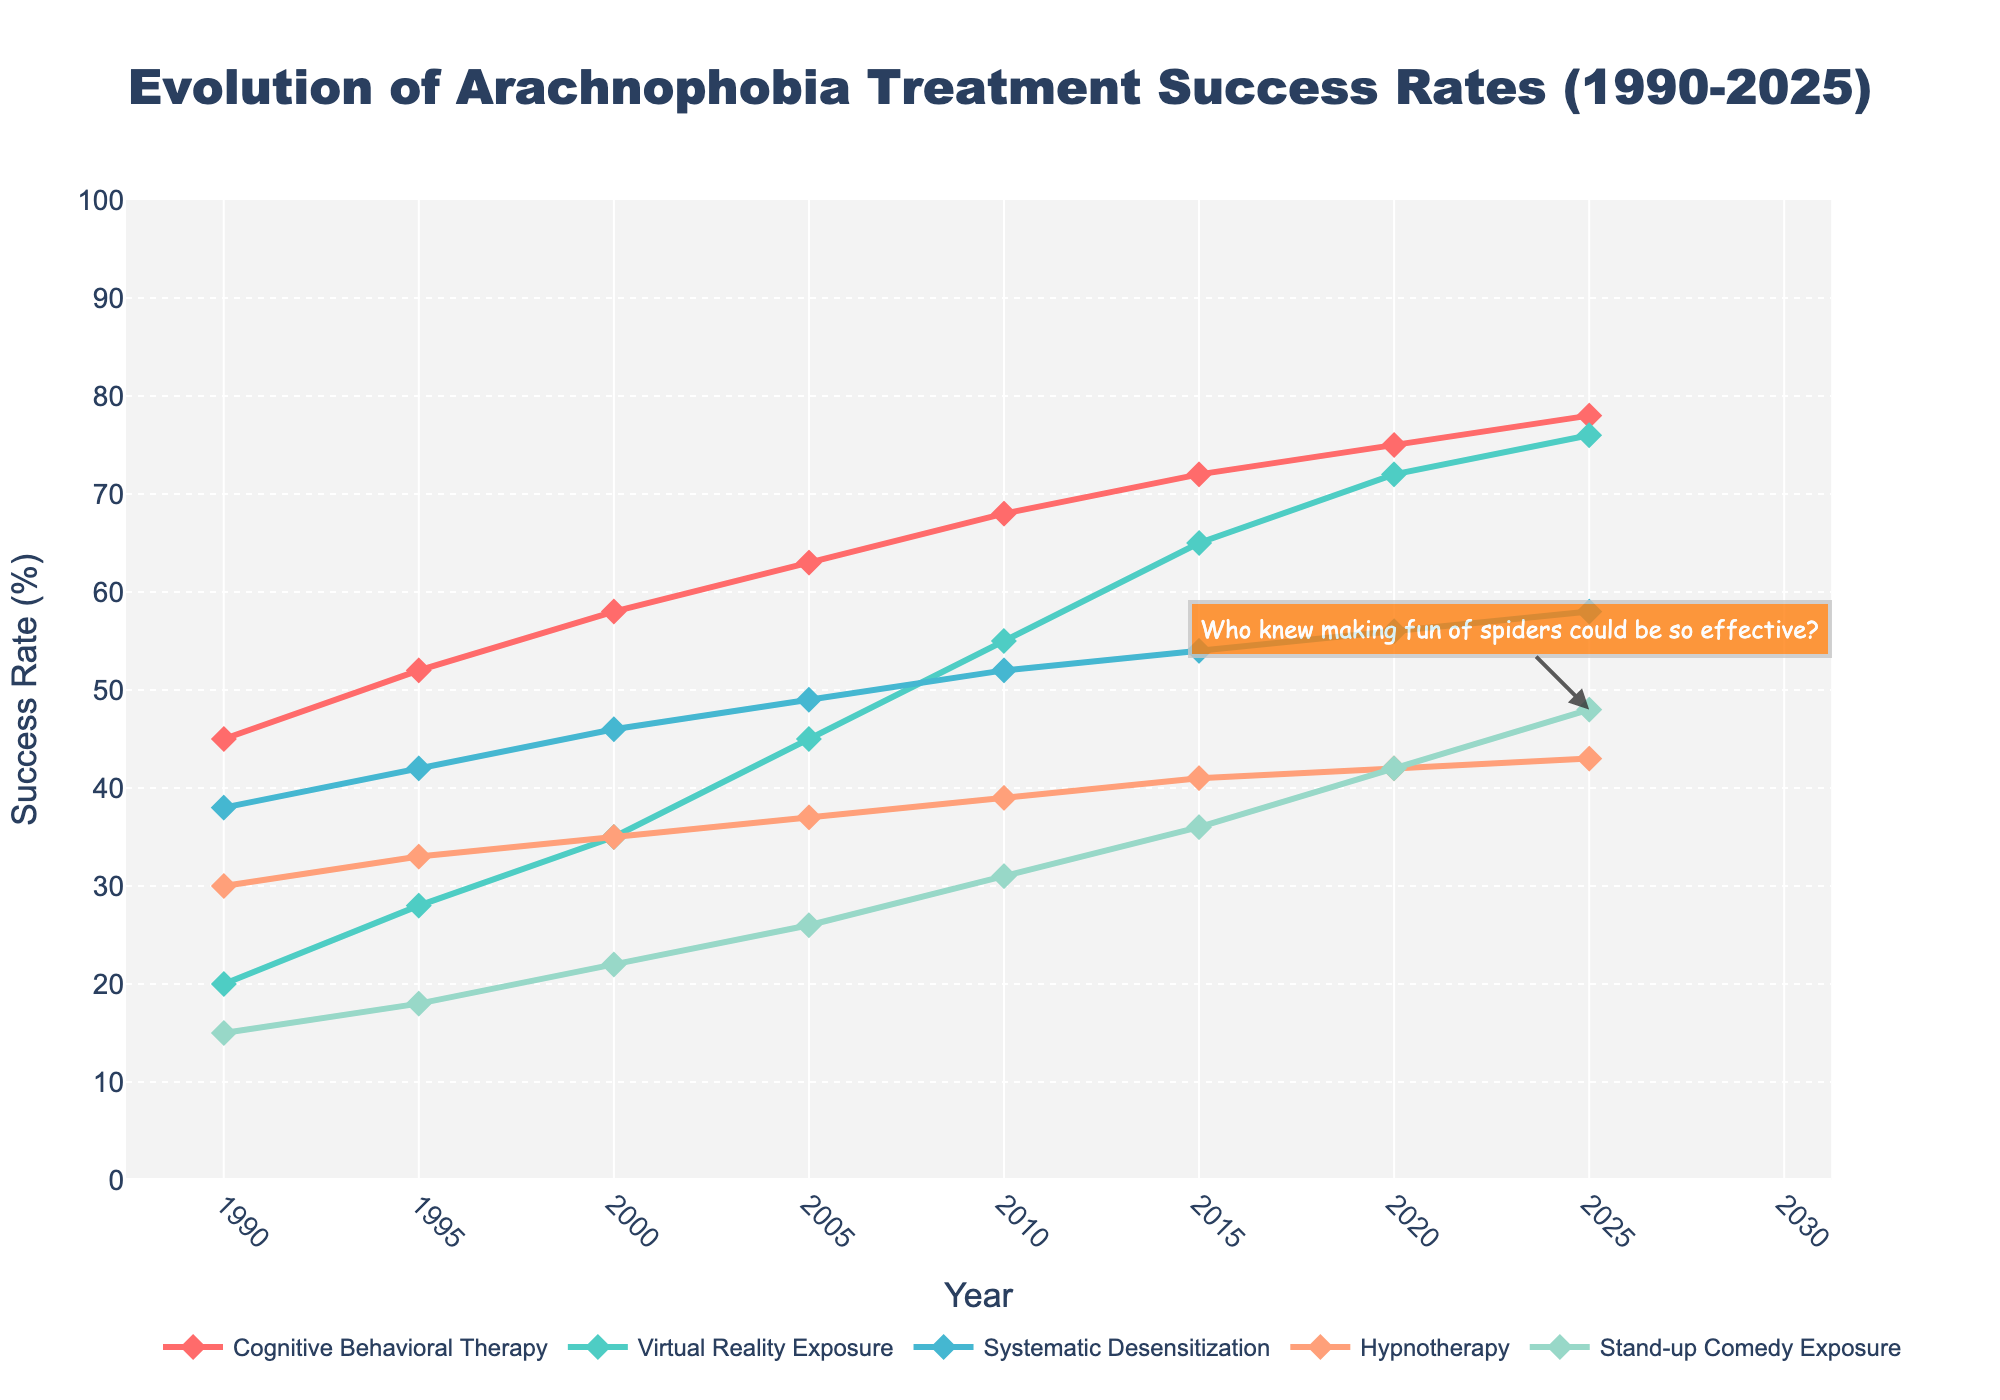What is the success rate of Cognitive Behavioral Therapy (CBT) in 2005? Look for the data point corresponding to Cognitive Behavioral Therapy in the year 2005 on the chart and read the value.
Answer: 63% Which therapy had the lowest success rate in 1995? Compare the success rates of all therapies in the year 1995 and identify the smallest value.
Answer: Stand-up Comedy Exposure How much did the success rate of Virtual Reality Exposure (VRE) increase from 2000 to 2020? Subtract the success rate of Virtual Reality Exposure in 2000 (35) from its rate in 2020 (72).
Answer: 37% In which year did Stand-up Comedy Exposure first surpass a 30% success rate? Identify the year when Stand-up Comedy Exposure's success rate first exceeded 30 by checking its trend over the years.
Answer: 2010 Which therapy shows the fastest improvement in success rates from 1990 to 2025? Observe the slope of the lines representing each therapy from 1990 to 2025 and compare their gradients to determine the steepest increase.
Answer: Virtual Reality Exposure Between 2015 and 2020, which therapy had the smallest increase in success rate? Compare the differences in success rates between 2015 and 2020 for each therapy and determine the smallest value.
Answer: Hypnotherapy What is the average success rate of Systematic Desensitization across the entire period? Calculate the sum of the success rates of Systematic Desensitization for all given years and divide by the number of years (8).
Answer: 49.375% In 2025, which therapy had a higher success rate, Cognitive Behavioral Therapy or Stand-up Comedy Exposure? Compare the success rate of Cognitive Behavioral Therapy (78) and Stand-up Comedy Exposure (48) in the year 2025.
Answer: Cognitive Behavioral Therapy What is the difference in success rates between Hypnotherapy and Stand-up Comedy Exposure in 2020? Subtract the success rate of Stand-up Comedy Exposure (42) from that of Hypnotherapy (42) in 2020.
Answer: 0 What is the trend of the success rate for Hypnotherapy from 1990 to 2025? Observe the line representing Hypnotherapy and describe the general direction it follows from beginning to end.
Answer: Slightly increasing 